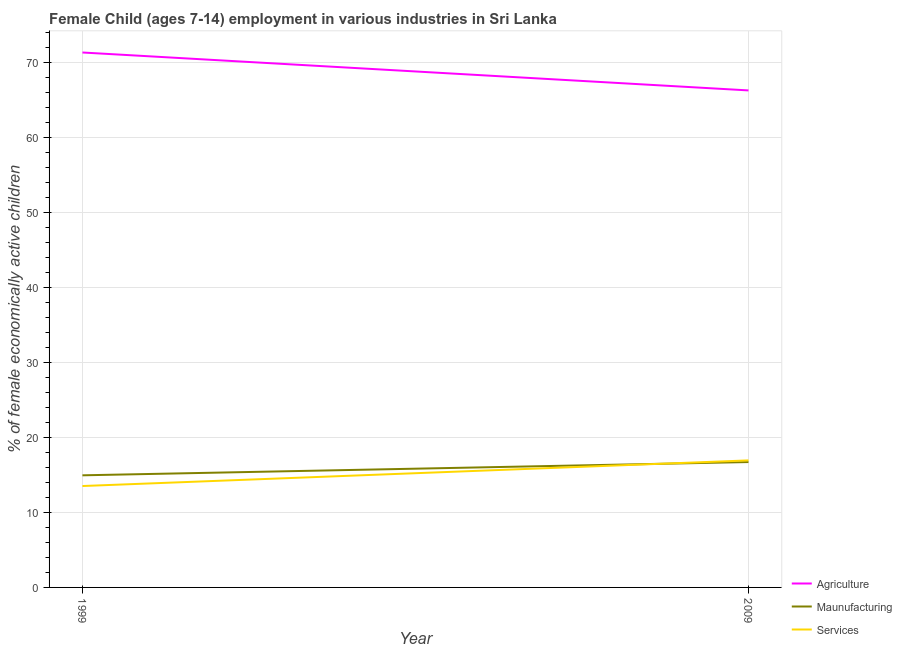How many different coloured lines are there?
Make the answer very short. 3. Does the line corresponding to percentage of economically active children in manufacturing intersect with the line corresponding to percentage of economically active children in agriculture?
Provide a succinct answer. No. Is the number of lines equal to the number of legend labels?
Your answer should be very brief. Yes. What is the percentage of economically active children in services in 1999?
Keep it short and to the point. 13.53. Across all years, what is the maximum percentage of economically active children in manufacturing?
Offer a very short reply. 16.73. Across all years, what is the minimum percentage of economically active children in manufacturing?
Your answer should be very brief. 14.96. What is the total percentage of economically active children in services in the graph?
Give a very brief answer. 30.48. What is the difference between the percentage of economically active children in manufacturing in 1999 and that in 2009?
Offer a terse response. -1.77. What is the difference between the percentage of economically active children in manufacturing in 1999 and the percentage of economically active children in agriculture in 2009?
Offer a terse response. -51.36. What is the average percentage of economically active children in manufacturing per year?
Offer a very short reply. 15.85. In the year 2009, what is the difference between the percentage of economically active children in services and percentage of economically active children in manufacturing?
Your answer should be compact. 0.22. In how many years, is the percentage of economically active children in services greater than 58 %?
Make the answer very short. 0. What is the ratio of the percentage of economically active children in agriculture in 1999 to that in 2009?
Your answer should be compact. 1.08. What is the difference between two consecutive major ticks on the Y-axis?
Ensure brevity in your answer.  10. Are the values on the major ticks of Y-axis written in scientific E-notation?
Give a very brief answer. No. Where does the legend appear in the graph?
Provide a short and direct response. Bottom right. How many legend labels are there?
Make the answer very short. 3. How are the legend labels stacked?
Offer a very short reply. Vertical. What is the title of the graph?
Your response must be concise. Female Child (ages 7-14) employment in various industries in Sri Lanka. What is the label or title of the X-axis?
Offer a very short reply. Year. What is the label or title of the Y-axis?
Give a very brief answer. % of female economically active children. What is the % of female economically active children in Agriculture in 1999?
Give a very brief answer. 71.38. What is the % of female economically active children in Maunufacturing in 1999?
Provide a short and direct response. 14.96. What is the % of female economically active children of Services in 1999?
Offer a very short reply. 13.53. What is the % of female economically active children in Agriculture in 2009?
Your answer should be very brief. 66.32. What is the % of female economically active children of Maunufacturing in 2009?
Your answer should be very brief. 16.73. What is the % of female economically active children of Services in 2009?
Provide a succinct answer. 16.95. Across all years, what is the maximum % of female economically active children of Agriculture?
Offer a very short reply. 71.38. Across all years, what is the maximum % of female economically active children of Maunufacturing?
Ensure brevity in your answer.  16.73. Across all years, what is the maximum % of female economically active children of Services?
Offer a very short reply. 16.95. Across all years, what is the minimum % of female economically active children of Agriculture?
Provide a short and direct response. 66.32. Across all years, what is the minimum % of female economically active children of Maunufacturing?
Offer a terse response. 14.96. Across all years, what is the minimum % of female economically active children in Services?
Keep it short and to the point. 13.53. What is the total % of female economically active children in Agriculture in the graph?
Offer a very short reply. 137.7. What is the total % of female economically active children of Maunufacturing in the graph?
Keep it short and to the point. 31.69. What is the total % of female economically active children in Services in the graph?
Ensure brevity in your answer.  30.48. What is the difference between the % of female economically active children in Agriculture in 1999 and that in 2009?
Make the answer very short. 5.06. What is the difference between the % of female economically active children in Maunufacturing in 1999 and that in 2009?
Make the answer very short. -1.77. What is the difference between the % of female economically active children of Services in 1999 and that in 2009?
Your answer should be compact. -3.42. What is the difference between the % of female economically active children of Agriculture in 1999 and the % of female economically active children of Maunufacturing in 2009?
Provide a succinct answer. 54.65. What is the difference between the % of female economically active children of Agriculture in 1999 and the % of female economically active children of Services in 2009?
Your answer should be compact. 54.43. What is the difference between the % of female economically active children in Maunufacturing in 1999 and the % of female economically active children in Services in 2009?
Provide a succinct answer. -1.99. What is the average % of female economically active children of Agriculture per year?
Your response must be concise. 68.85. What is the average % of female economically active children in Maunufacturing per year?
Your response must be concise. 15.85. What is the average % of female economically active children of Services per year?
Make the answer very short. 15.24. In the year 1999, what is the difference between the % of female economically active children of Agriculture and % of female economically active children of Maunufacturing?
Keep it short and to the point. 56.42. In the year 1999, what is the difference between the % of female economically active children in Agriculture and % of female economically active children in Services?
Your answer should be very brief. 57.85. In the year 1999, what is the difference between the % of female economically active children in Maunufacturing and % of female economically active children in Services?
Provide a short and direct response. 1.43. In the year 2009, what is the difference between the % of female economically active children of Agriculture and % of female economically active children of Maunufacturing?
Provide a succinct answer. 49.59. In the year 2009, what is the difference between the % of female economically active children in Agriculture and % of female economically active children in Services?
Offer a terse response. 49.37. In the year 2009, what is the difference between the % of female economically active children of Maunufacturing and % of female economically active children of Services?
Offer a very short reply. -0.22. What is the ratio of the % of female economically active children in Agriculture in 1999 to that in 2009?
Keep it short and to the point. 1.08. What is the ratio of the % of female economically active children of Maunufacturing in 1999 to that in 2009?
Your answer should be very brief. 0.89. What is the ratio of the % of female economically active children of Services in 1999 to that in 2009?
Ensure brevity in your answer.  0.8. What is the difference between the highest and the second highest % of female economically active children of Agriculture?
Your answer should be compact. 5.06. What is the difference between the highest and the second highest % of female economically active children of Maunufacturing?
Offer a very short reply. 1.77. What is the difference between the highest and the second highest % of female economically active children of Services?
Your answer should be very brief. 3.42. What is the difference between the highest and the lowest % of female economically active children in Agriculture?
Offer a very short reply. 5.06. What is the difference between the highest and the lowest % of female economically active children in Maunufacturing?
Make the answer very short. 1.77. What is the difference between the highest and the lowest % of female economically active children of Services?
Your answer should be very brief. 3.42. 